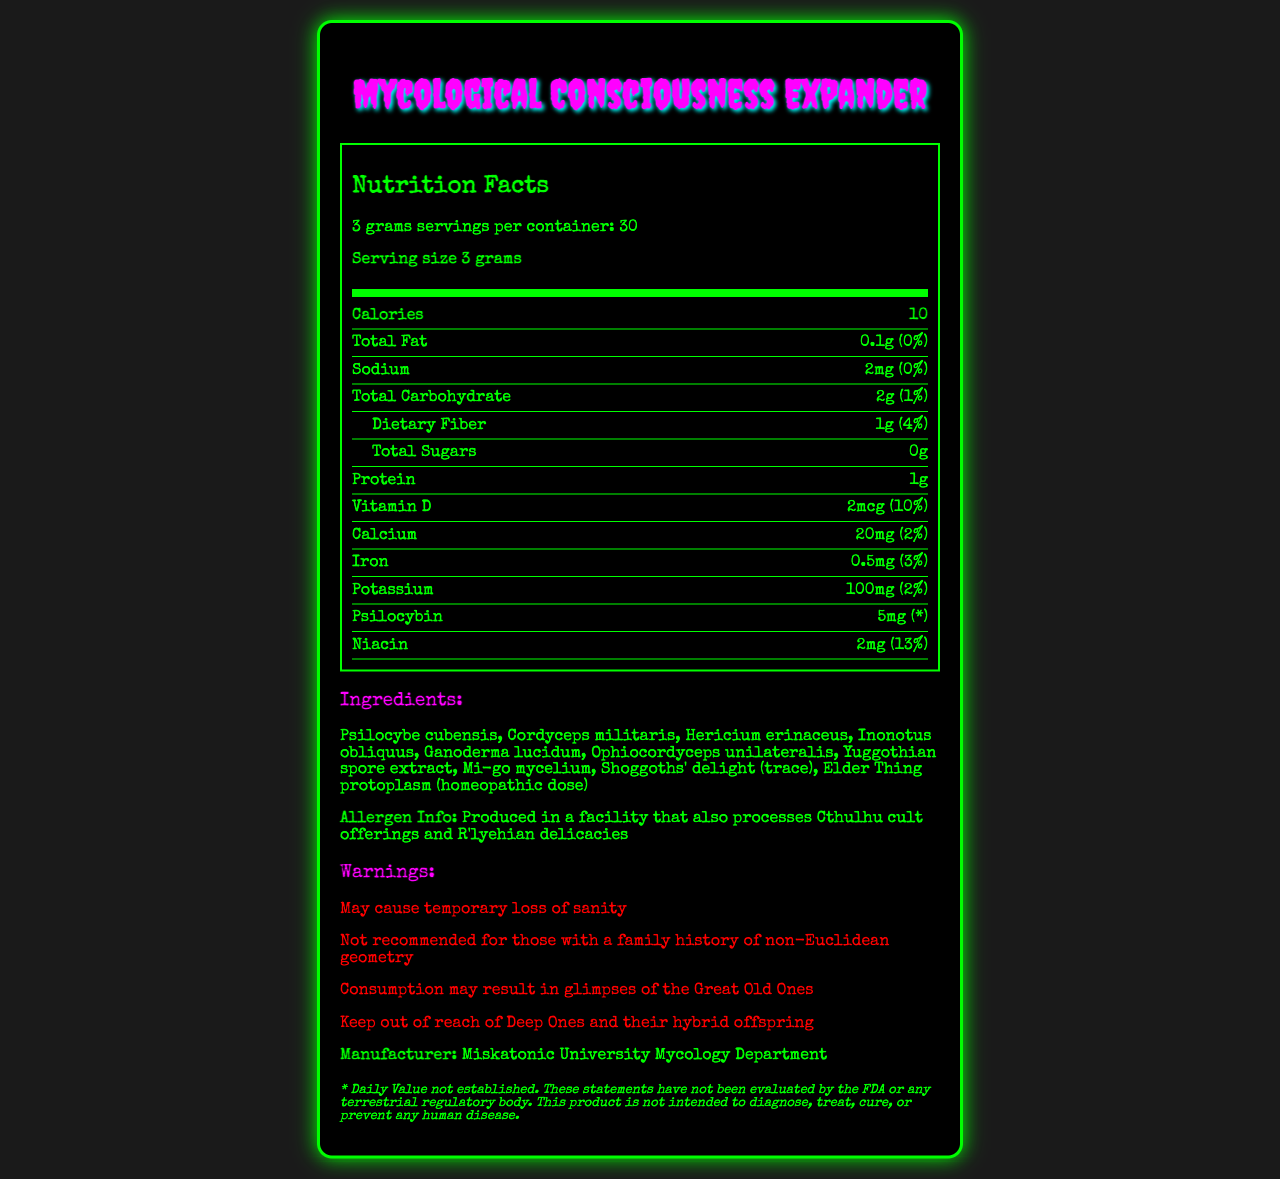what is the serving size? The serving size is explicitly mentioned in the document as "3 grams".
Answer: 3 grams how many servings are in a container? The document states there are 30 servings per container.
Answer: 30 servings how many calories are in each serving? The document lists the calories for each serving as "10".
Answer: 10 calories how much protein is in each serving? The document specifies that each serving contains 1 gram of protein.
Answer: 1 gram how much psilocybin is in each serving? The amount of psilocybin per serving is listed as 5 mg in the document.
Answer: 5 mg what is the main purpose of the warnings section? The warnings section lists several potential effects and cautions, such as "May cause temporary loss of sanity" and "Not recommended for those with a family history of non-Euclidean geometry".
Answer: To provide cautionary advice regarding the potential effects and risks of consuming the product. what is the daily value percentage for niacin per serving?
A. 2%
B. 10%
C. 13%
D. 30% The document specifies that the daily value percentage for niacin per serving is 13%.
Answer: C. 13% which of the following ingredients is used in a homeopathic dose?
I. Ophiocordyceps unilateralis
II. Shoggoths' delight
III. Elder Thing protoplasm The document mentions "Elder Thing protoplasm (homeopathic dose)" under ingredients.
Answer: III. Elder Thing protoplasm is this product evaluated by the FDA? The disclaimer at the end of the document states that "These statements have not been evaluated by the FDA or any terrestrial regulatory body."
Answer: No summarize the main idea of the document. The document describes a unique product's nutritional profile, ingredients, potential cautions, and manufacturer information, emphasizing its fictional and fantastical nature.
Answer: The document provides nutrition facts and other relevant information about a fictional product named "Mycological Consciousness Expander", which is a blend of various earthly and alien fungi. It includes specific serving size, servings per container, and nutritional contents such as calories, fats, carbohydrates, and protein. The ingredients and allergen information, warnings regarding potential effects, manufacturer details, and a disclaimer are also presented. who is the target audience for this product? The document does not provide specific information on who the target audience is for this product.
Answer: Cannot be determined what is the amount of iron per serving? The document states that each serving contains 0.5 mg of iron.
Answer: 0.5 mg are there any sugars in this product? The total sugars are listed as "0g" in the nutrition facts.
Answer: No how much dietary fiber is in a serving? Each serving contains 1 gram of dietary fiber as per the document.
Answer: 1 gram 